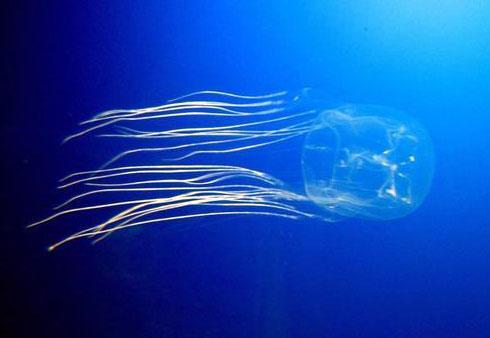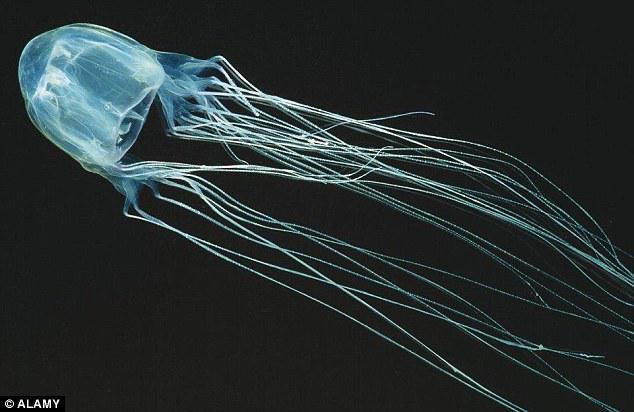The first image is the image on the left, the second image is the image on the right. Evaluate the accuracy of this statement regarding the images: "There are exactly two jellyfish and no humans, and at least one jellyfish is facing to the right.". Is it true? Answer yes or no. Yes. 